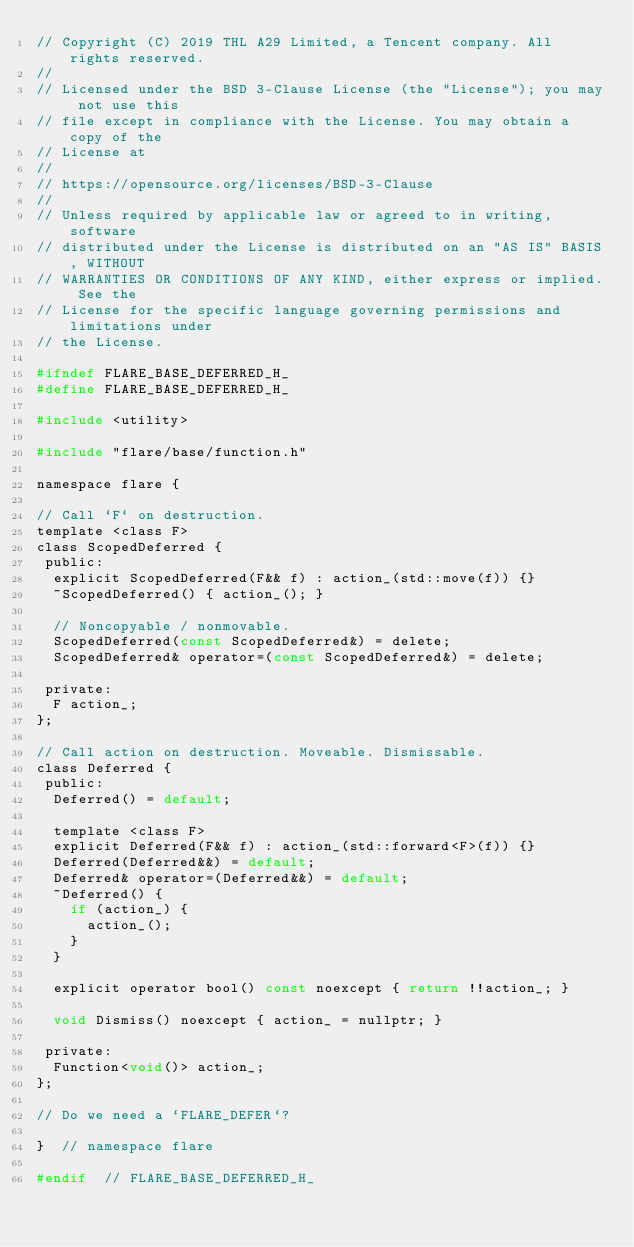<code> <loc_0><loc_0><loc_500><loc_500><_C_>// Copyright (C) 2019 THL A29 Limited, a Tencent company. All rights reserved.
//
// Licensed under the BSD 3-Clause License (the "License"); you may not use this
// file except in compliance with the License. You may obtain a copy of the
// License at
//
// https://opensource.org/licenses/BSD-3-Clause
//
// Unless required by applicable law or agreed to in writing, software
// distributed under the License is distributed on an "AS IS" BASIS, WITHOUT
// WARRANTIES OR CONDITIONS OF ANY KIND, either express or implied. See the
// License for the specific language governing permissions and limitations under
// the License.

#ifndef FLARE_BASE_DEFERRED_H_
#define FLARE_BASE_DEFERRED_H_

#include <utility>

#include "flare/base/function.h"

namespace flare {

// Call `F` on destruction.
template <class F>
class ScopedDeferred {
 public:
  explicit ScopedDeferred(F&& f) : action_(std::move(f)) {}
  ~ScopedDeferred() { action_(); }

  // Noncopyable / nonmovable.
  ScopedDeferred(const ScopedDeferred&) = delete;
  ScopedDeferred& operator=(const ScopedDeferred&) = delete;

 private:
  F action_;
};

// Call action on destruction. Moveable. Dismissable.
class Deferred {
 public:
  Deferred() = default;

  template <class F>
  explicit Deferred(F&& f) : action_(std::forward<F>(f)) {}
  Deferred(Deferred&&) = default;
  Deferred& operator=(Deferred&&) = default;
  ~Deferred() {
    if (action_) {
      action_();
    }
  }

  explicit operator bool() const noexcept { return !!action_; }

  void Dismiss() noexcept { action_ = nullptr; }

 private:
  Function<void()> action_;
};

// Do we need a `FLARE_DEFER`?

}  // namespace flare

#endif  // FLARE_BASE_DEFERRED_H_
</code> 